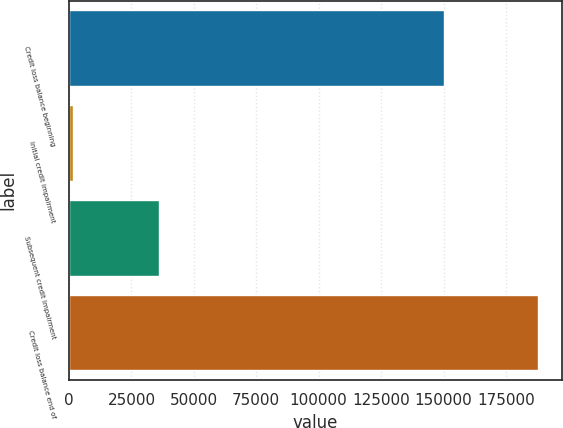Convert chart to OTSL. <chart><loc_0><loc_0><loc_500><loc_500><bar_chart><fcel>Credit loss balance beginning<fcel>Initial credit impairment<fcel>Subsequent credit impairment<fcel>Credit loss balance end of<nl><fcel>150372<fcel>1642<fcel>36024<fcel>188038<nl></chart> 